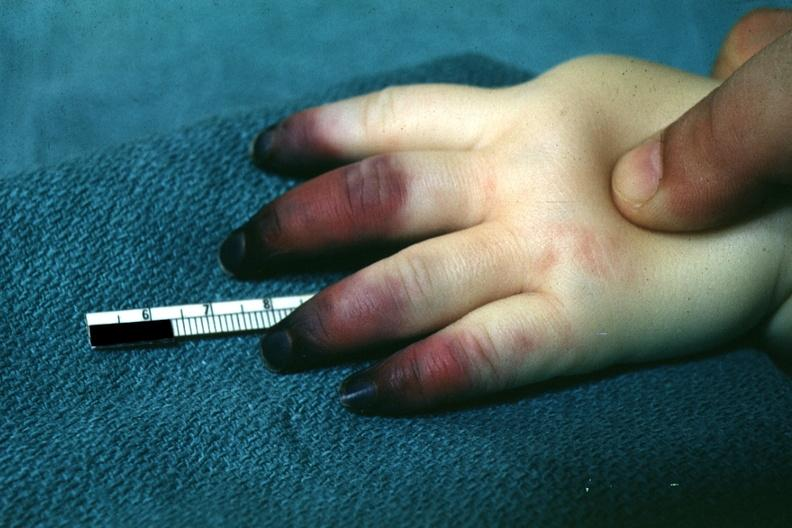what are present?
Answer the question using a single word or phrase. Extremities 